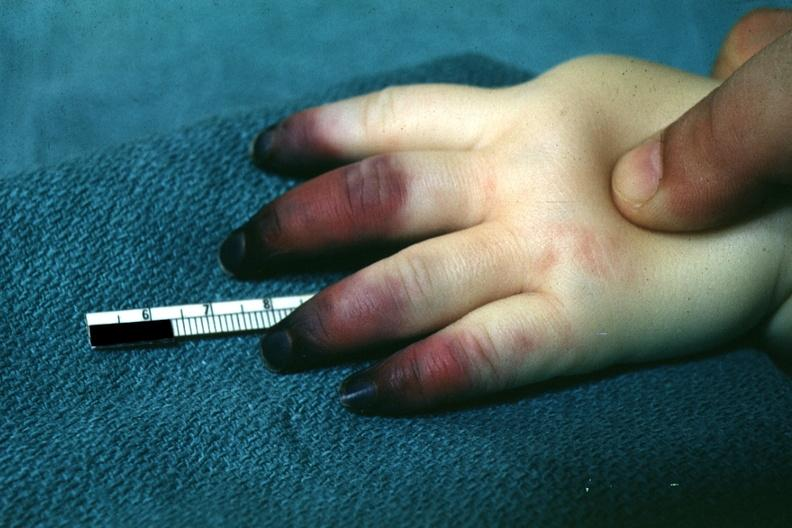what are present?
Answer the question using a single word or phrase. Extremities 